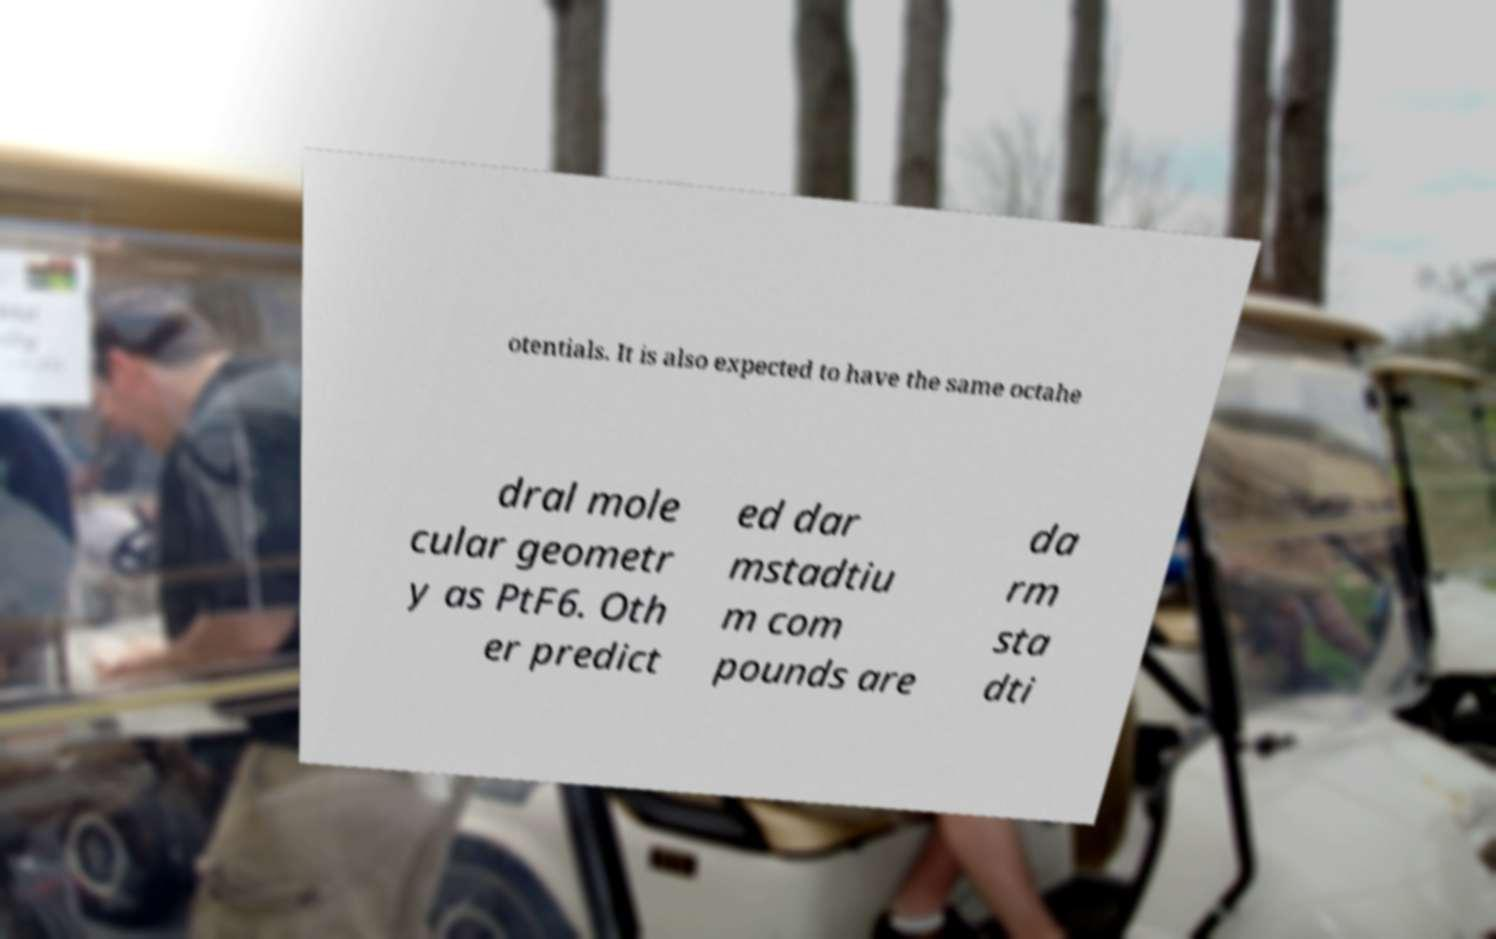Could you assist in decoding the text presented in this image and type it out clearly? otentials. It is also expected to have the same octahe dral mole cular geometr y as PtF6. Oth er predict ed dar mstadtiu m com pounds are da rm sta dti 